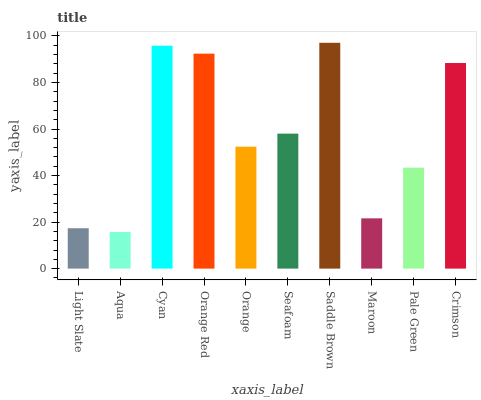Is Aqua the minimum?
Answer yes or no. Yes. Is Saddle Brown the maximum?
Answer yes or no. Yes. Is Cyan the minimum?
Answer yes or no. No. Is Cyan the maximum?
Answer yes or no. No. Is Cyan greater than Aqua?
Answer yes or no. Yes. Is Aqua less than Cyan?
Answer yes or no. Yes. Is Aqua greater than Cyan?
Answer yes or no. No. Is Cyan less than Aqua?
Answer yes or no. No. Is Seafoam the high median?
Answer yes or no. Yes. Is Orange the low median?
Answer yes or no. Yes. Is Light Slate the high median?
Answer yes or no. No. Is Saddle Brown the low median?
Answer yes or no. No. 